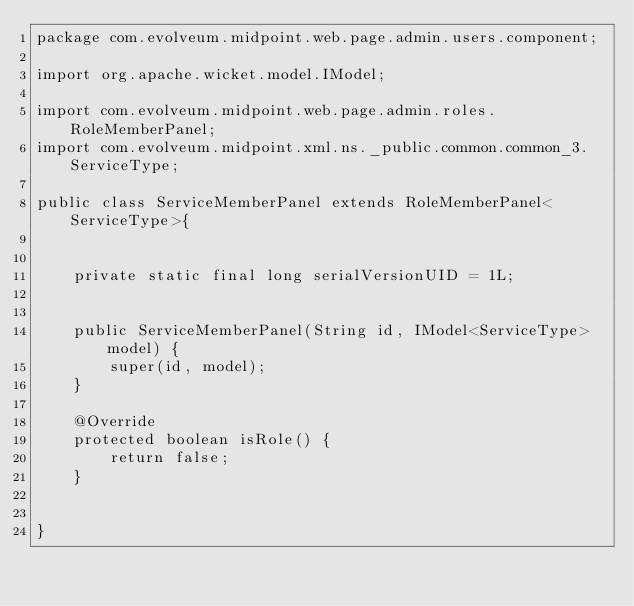Convert code to text. <code><loc_0><loc_0><loc_500><loc_500><_Java_>package com.evolveum.midpoint.web.page.admin.users.component;

import org.apache.wicket.model.IModel;

import com.evolveum.midpoint.web.page.admin.roles.RoleMemberPanel;
import com.evolveum.midpoint.xml.ns._public.common.common_3.ServiceType;

public class ServiceMemberPanel extends RoleMemberPanel<ServiceType>{


	private static final long serialVersionUID = 1L;


	public ServiceMemberPanel(String id, IModel<ServiceType> model) {
		super(id, model);
	}

	@Override
	protected boolean isRole() {
		return false;
	}


}
</code> 